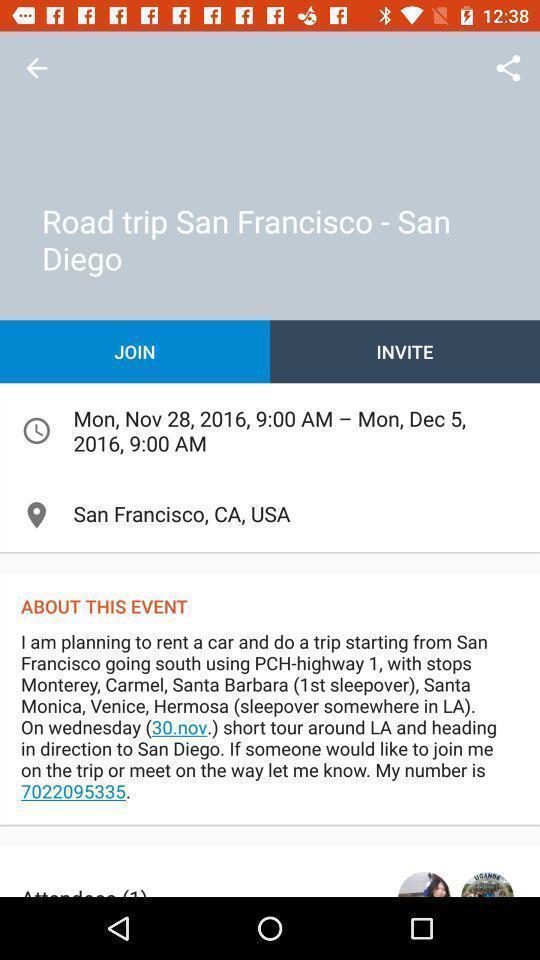Tell me about the visual elements in this screen capture. Screen displaying event details. 